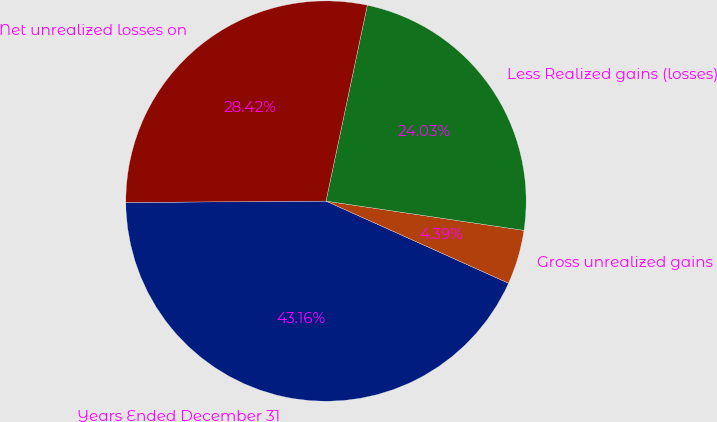Convert chart. <chart><loc_0><loc_0><loc_500><loc_500><pie_chart><fcel>Years Ended December 31<fcel>Gross unrealized gains<fcel>Less Realized gains (losses)<fcel>Net unrealized losses on<nl><fcel>43.16%<fcel>4.39%<fcel>24.03%<fcel>28.42%<nl></chart> 